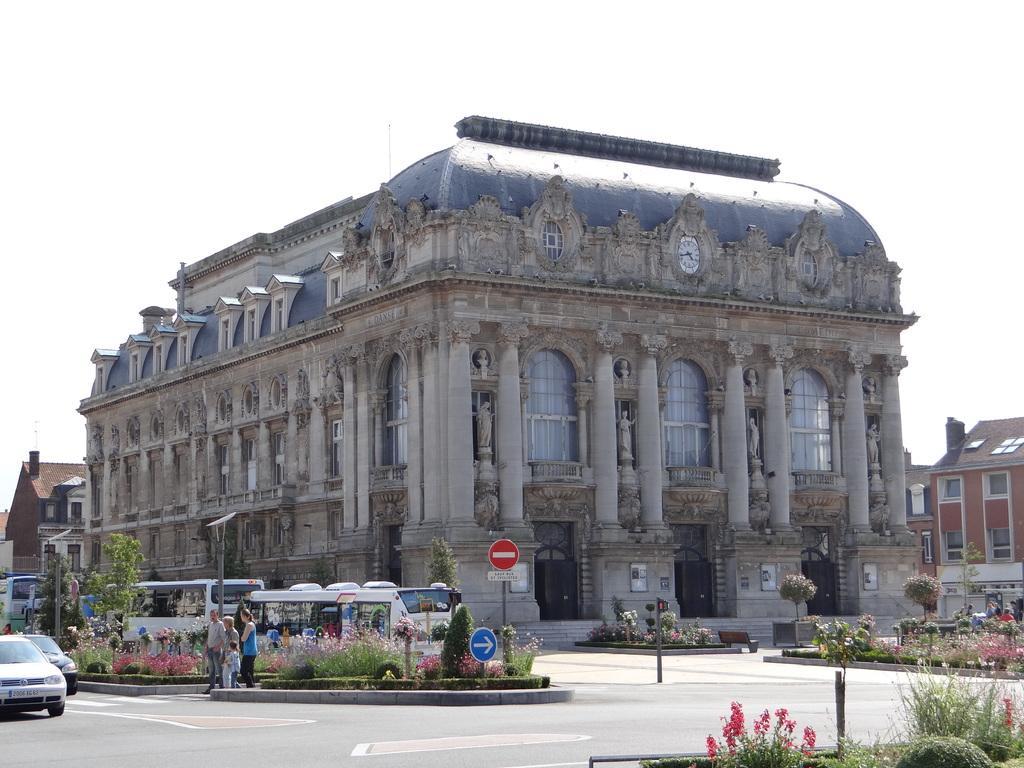Please provide a concise description of this image. At the center of the image there are buildings, in front of the buildings there are few vehicles parked and few vehicles are moving on the road, in the middle of the road there are trees and plants and few people are standing and there are few sign boards. In the background there is the sky. 